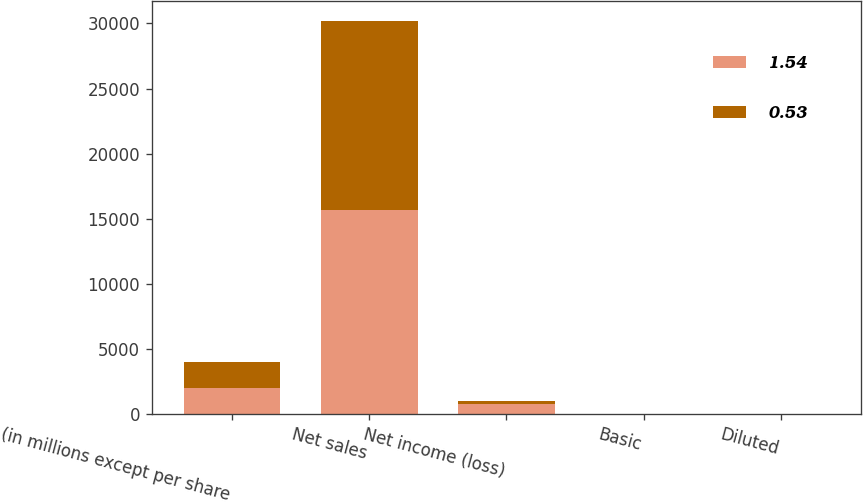Convert chart. <chart><loc_0><loc_0><loc_500><loc_500><stacked_bar_chart><ecel><fcel>(in millions except per share<fcel>Net sales<fcel>Net income (loss)<fcel>Basic<fcel>Diluted<nl><fcel>1.54<fcel>2016<fcel>15657.6<fcel>748<fcel>1.55<fcel>1.54<nl><fcel>0.53<fcel>2015<fcel>14519.6<fcel>254.9<fcel>0.53<fcel>0.53<nl></chart> 